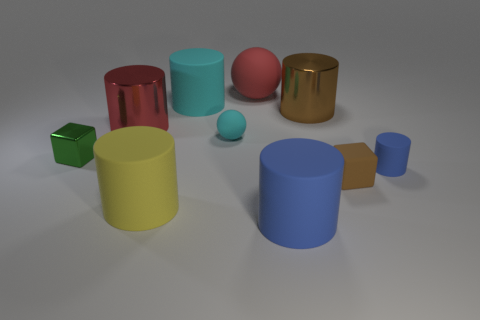Are there any objects with distinct textures or reflective surfaces? Indeed, the golden cylinder and the red object both have reflective surfaces which make them stand out against the matte finish of the other items. 